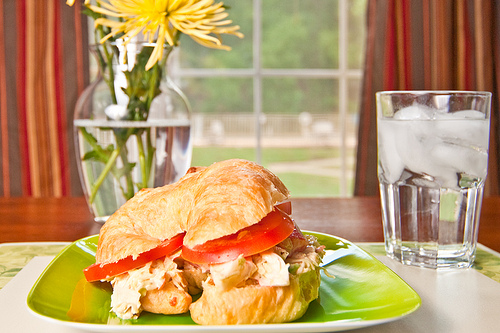What color is the pastry on the plate? The pastry on the plate is golden brown in color. 